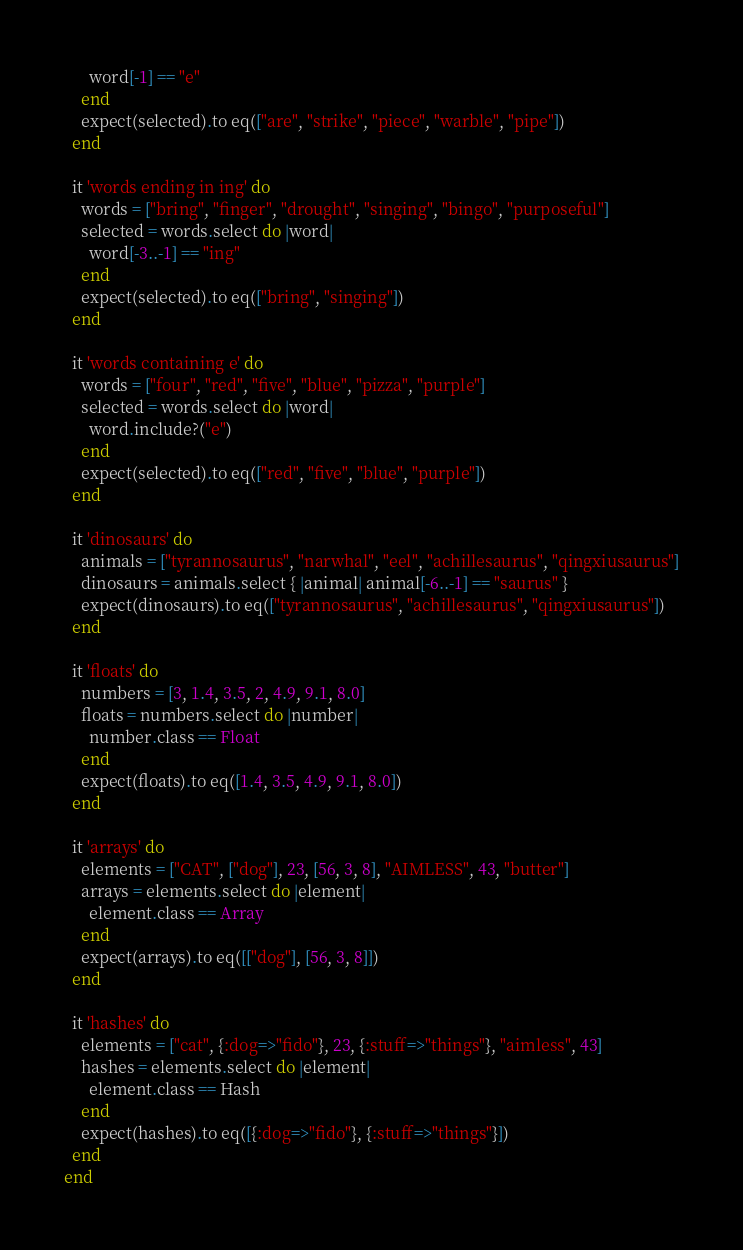Convert code to text. <code><loc_0><loc_0><loc_500><loc_500><_Ruby_>      word[-1] == "e"
    end
    expect(selected).to eq(["are", "strike", "piece", "warble", "pipe"])
  end

  it 'words ending in ing' do
    words = ["bring", "finger", "drought", "singing", "bingo", "purposeful"]
    selected = words.select do |word|
      word[-3..-1] == "ing"
    end
    expect(selected).to eq(["bring", "singing"])
  end

  it 'words containing e' do
    words = ["four", "red", "five", "blue", "pizza", "purple"]
    selected = words.select do |word|
      word.include?("e")
    end
    expect(selected).to eq(["red", "five", "blue", "purple"])
  end

  it 'dinosaurs' do
    animals = ["tyrannosaurus", "narwhal", "eel", "achillesaurus", "qingxiusaurus"]
    dinosaurs = animals.select { |animal| animal[-6..-1] == "saurus" }
    expect(dinosaurs).to eq(["tyrannosaurus", "achillesaurus", "qingxiusaurus"])
  end

  it 'floats' do
    numbers = [3, 1.4, 3.5, 2, 4.9, 9.1, 8.0]
    floats = numbers.select do |number|
      number.class == Float
    end
    expect(floats).to eq([1.4, 3.5, 4.9, 9.1, 8.0])
  end

  it 'arrays' do
    elements = ["CAT", ["dog"], 23, [56, 3, 8], "AIMLESS", 43, "butter"]
    arrays = elements.select do |element|
      element.class == Array
    end
    expect(arrays).to eq([["dog"], [56, 3, 8]])
  end

  it 'hashes' do
    elements = ["cat", {:dog=>"fido"}, 23, {:stuff=>"things"}, "aimless", 43]
    hashes = elements.select do |element|
      element.class == Hash
    end 
    expect(hashes).to eq([{:dog=>"fido"}, {:stuff=>"things"}])
  end
end
</code> 